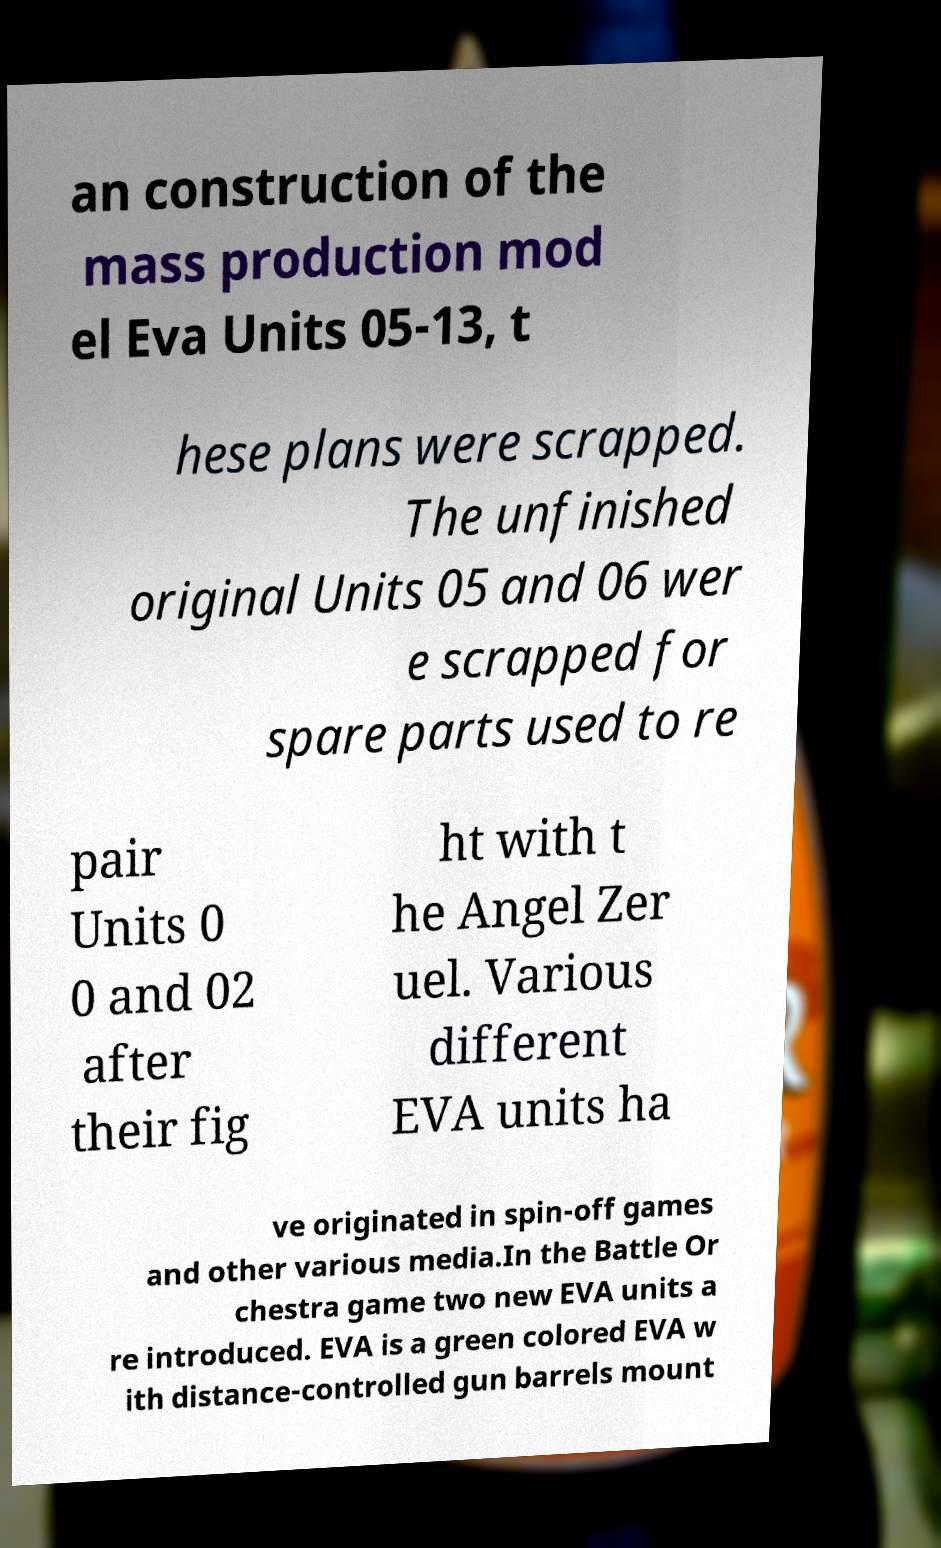There's text embedded in this image that I need extracted. Can you transcribe it verbatim? an construction of the mass production mod el Eva Units 05-13, t hese plans were scrapped. The unfinished original Units 05 and 06 wer e scrapped for spare parts used to re pair Units 0 0 and 02 after their fig ht with t he Angel Zer uel. Various different EVA units ha ve originated in spin-off games and other various media.In the Battle Or chestra game two new EVA units a re introduced. EVA is a green colored EVA w ith distance-controlled gun barrels mount 